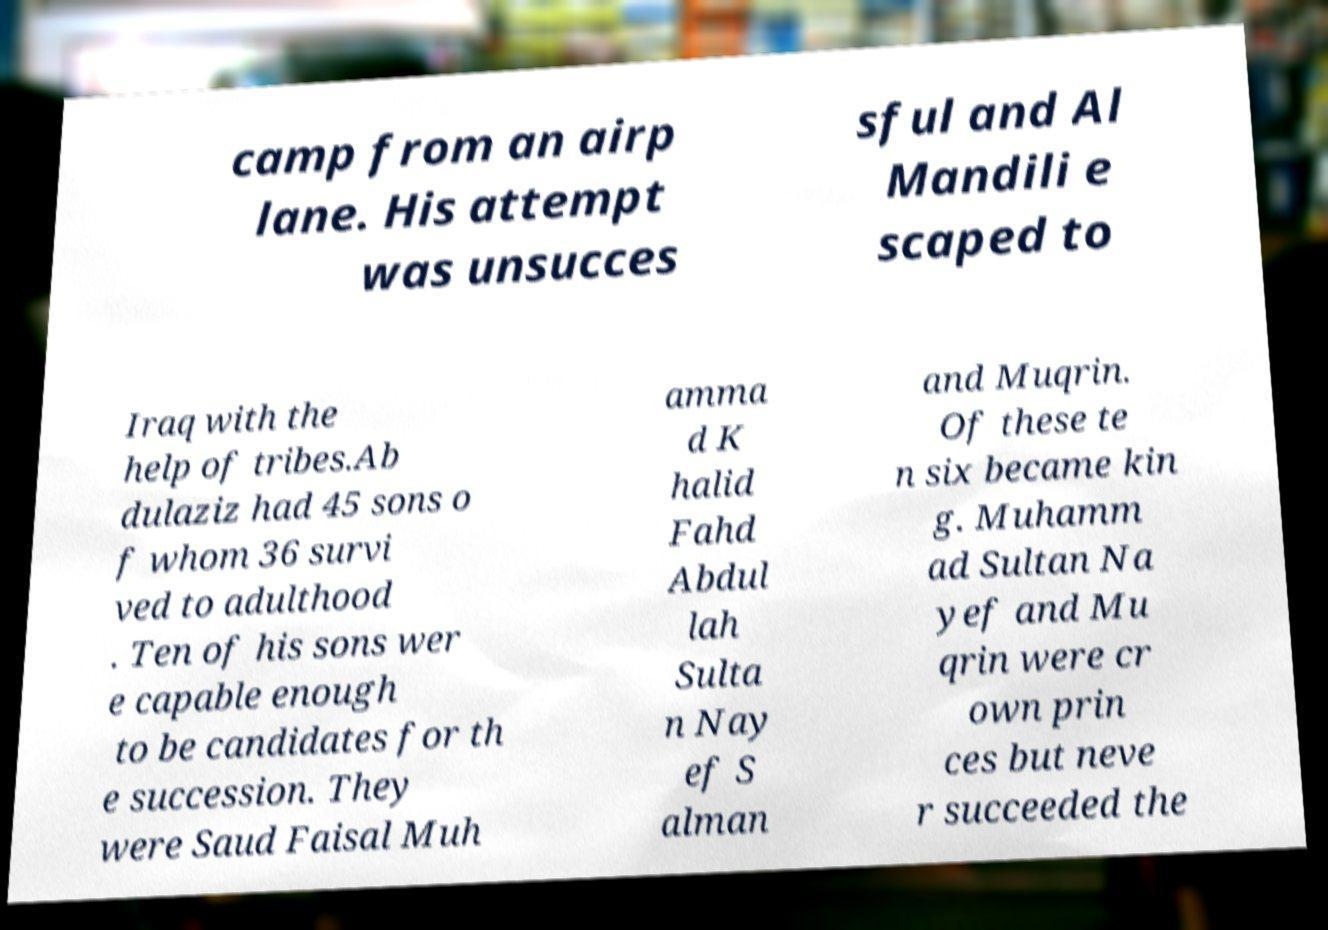Can you accurately transcribe the text from the provided image for me? camp from an airp lane. His attempt was unsucces sful and Al Mandili e scaped to Iraq with the help of tribes.Ab dulaziz had 45 sons o f whom 36 survi ved to adulthood . Ten of his sons wer e capable enough to be candidates for th e succession. They were Saud Faisal Muh amma d K halid Fahd Abdul lah Sulta n Nay ef S alman and Muqrin. Of these te n six became kin g. Muhamm ad Sultan Na yef and Mu qrin were cr own prin ces but neve r succeeded the 